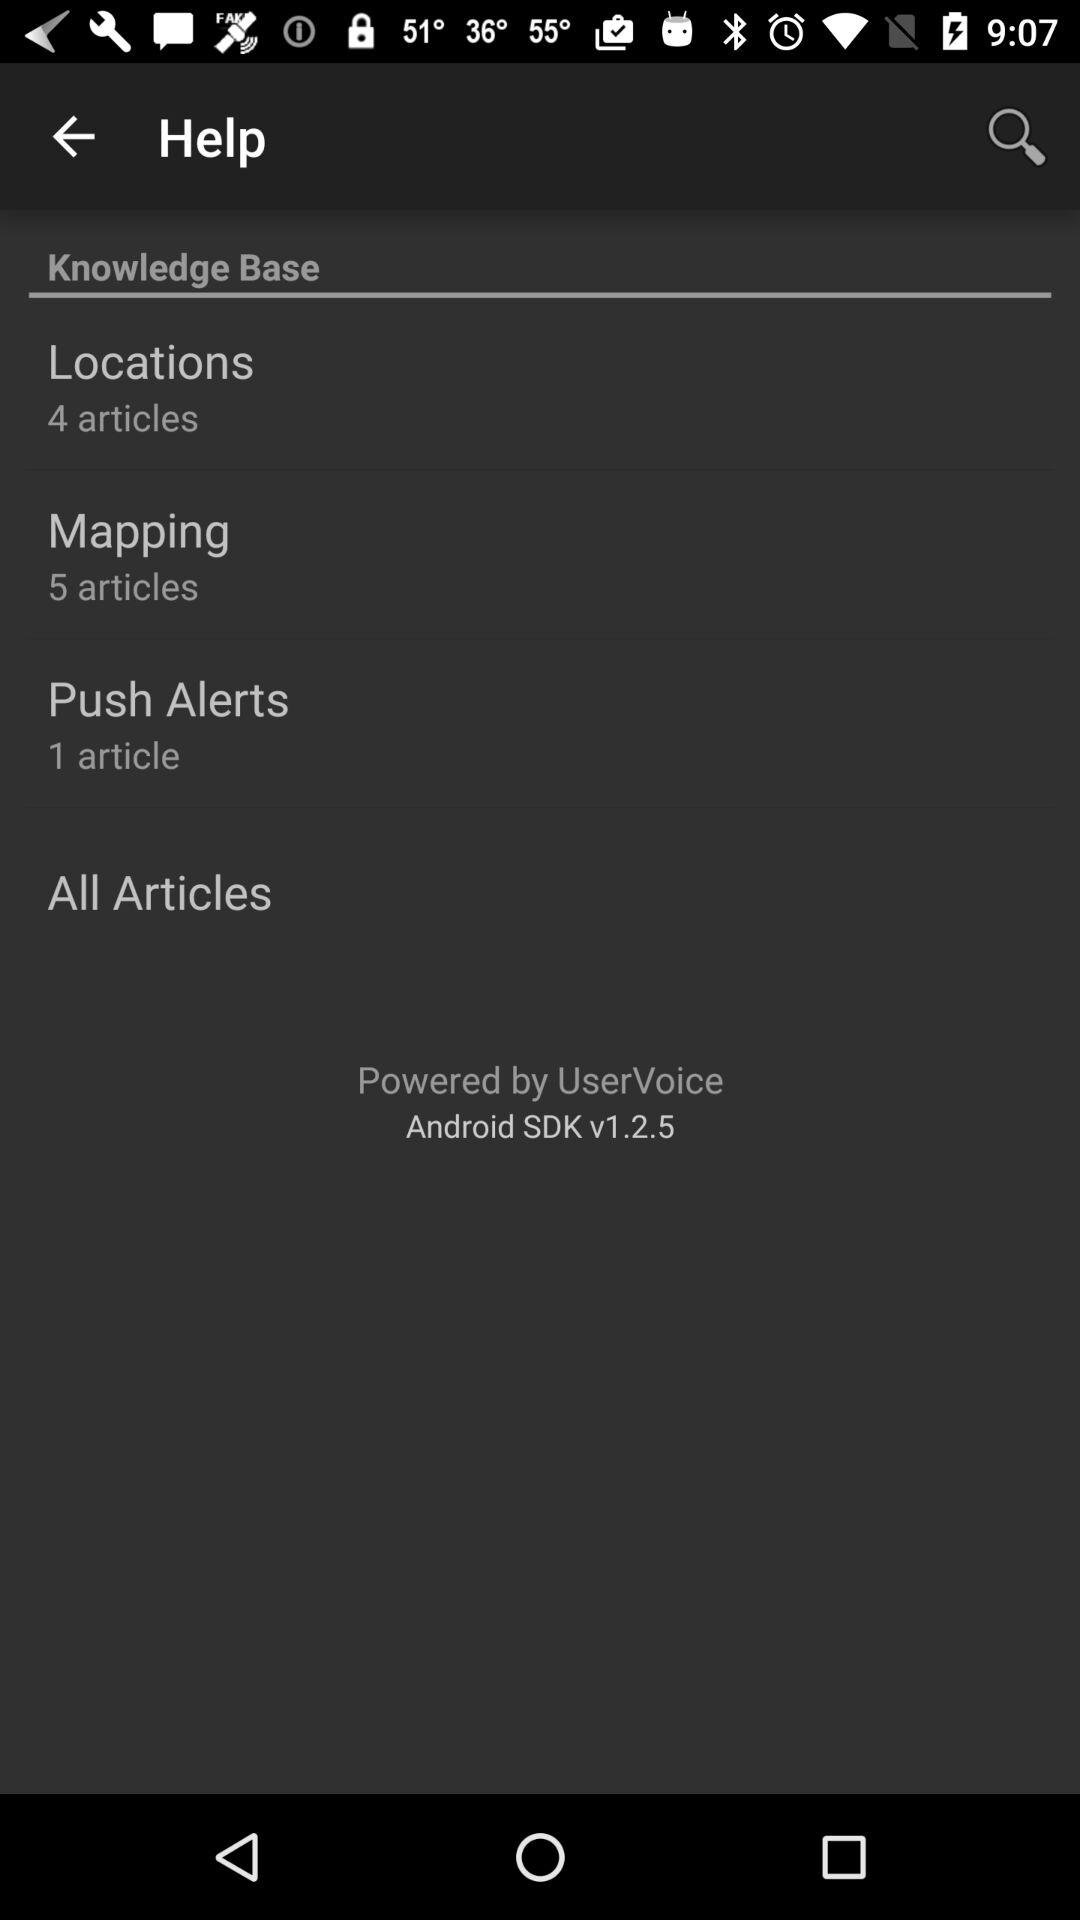What is the version of the app? The version of the app is v1.2.5. 